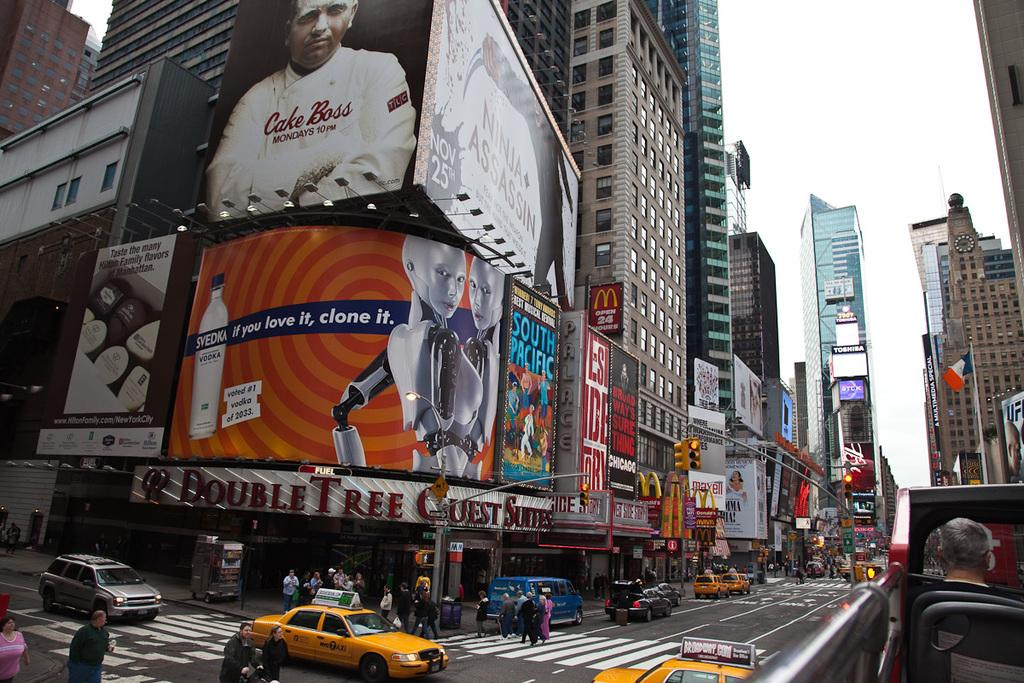What type of structures can be seen in the image? There are buildings in the image. What type of signs are visible in the image? There are advertisements and posters in the image. What type of establishments can be found in the image? There are stores in the image. Who or what is present in the image? There are persons in the image. What type of pathway is visible in the image? There is a road in the image. What type of transportation is present in the image? There are vehicles in the image. What type of symbol is visible in the image? There is a flag in the image. What type of traffic control devices are visible in the image? There are traffic signals in the image. What part of the natural environment is visible in the image? The sky is visible in the image. Where is the cactus located in the image? There is no cactus present in the image. What sense is being used by the persons in the image? The provided facts do not give information about the senses being used by the persons in the image. 